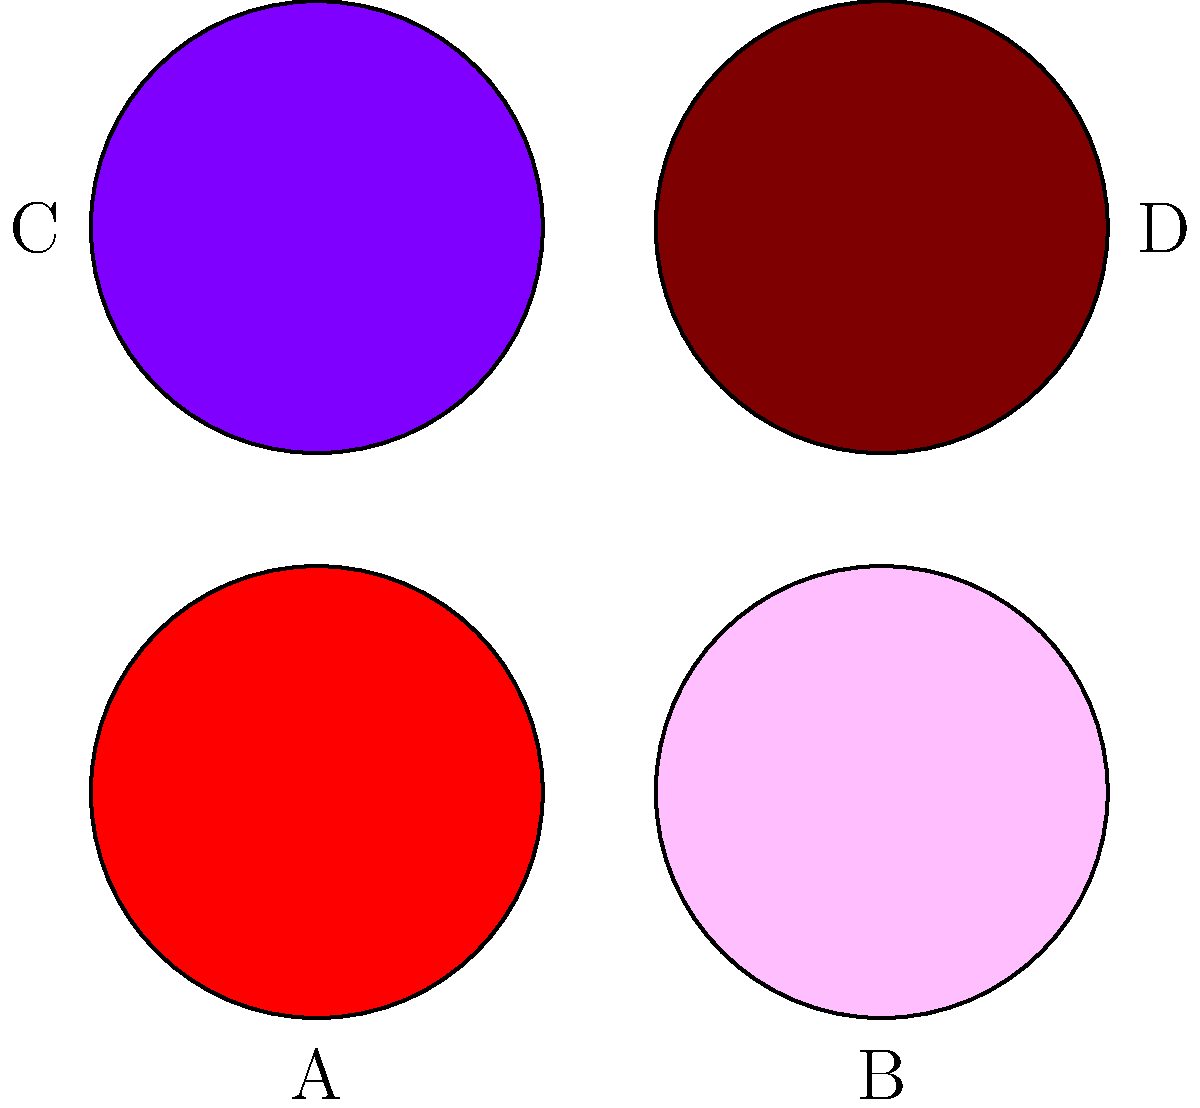Identify the wound types represented by the images A, B, C, and D, and classify them according to their stages. To identify the wound types and classify their stages, we need to analyze the visual characteristics of each image:

1. Image A (Red):
   - Bright red color
   - Appears moist and granular
   - Characteristics of a Stage 2 Pressure Ulcer

2. Image B (Pink):
   - Pink or light red color
   - Smooth appearance
   - Represents a Stage 1 Pressure Ulcer

3. Image C (Purple):
   - Deep purple or maroon color
   - Indicates deep tissue injury
   - Classified as a Suspected Deep Tissue Injury (SDTI)

4. Image D (Brown):
   - Brown or black color
   - Appears dry and leathery
   - Represents an Unstageable Pressure Ulcer (due to eschar)

The classification is based on the National Pressure Ulcer Advisory Panel (NPUAP) staging system for pressure ulcers.
Answer: A: Stage 2 Pressure Ulcer, B: Stage 1 Pressure Ulcer, C: Suspected Deep Tissue Injury, D: Unstageable Pressure Ulcer 